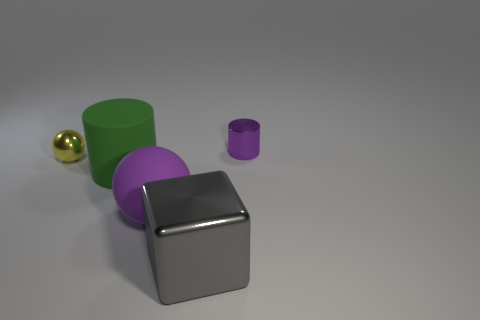Add 1 large brown shiny blocks. How many objects exist? 6 Subtract all yellow spheres. How many spheres are left? 1 Subtract all cylinders. How many objects are left? 3 Subtract 1 spheres. How many spheres are left? 1 Subtract all green rubber cylinders. Subtract all big balls. How many objects are left? 3 Add 1 purple shiny cylinders. How many purple shiny cylinders are left? 2 Add 3 purple metal cylinders. How many purple metal cylinders exist? 4 Subtract 0 gray cylinders. How many objects are left? 5 Subtract all green cubes. Subtract all gray spheres. How many cubes are left? 1 